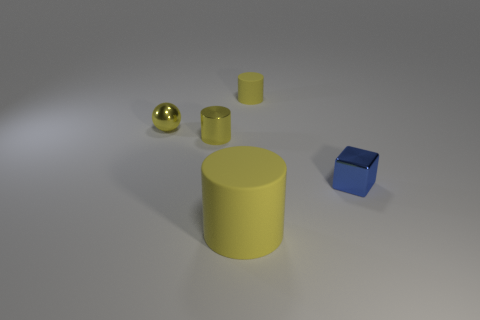What shape is the matte object in front of the matte cylinder right of the yellow object that is in front of the blue shiny cube?
Make the answer very short. Cylinder. Are there any matte cylinders that have the same size as the metal sphere?
Make the answer very short. Yes. The metallic block has what size?
Your answer should be very brief. Small. What number of objects have the same size as the yellow ball?
Provide a succinct answer. 3. Is the number of tiny cylinders in front of the small rubber object less than the number of tiny yellow objects to the right of the large matte thing?
Offer a terse response. No. There is a matte object that is to the left of the yellow rubber object behind the cylinder in front of the cube; what size is it?
Make the answer very short. Large. What is the size of the yellow thing that is behind the tiny metal cylinder and in front of the tiny matte object?
Offer a terse response. Small. There is a tiny thing that is to the right of the cylinder that is on the right side of the big yellow rubber object; what shape is it?
Keep it short and to the point. Cube. Are there any other things of the same color as the shiny ball?
Offer a very short reply. Yes. What shape is the object in front of the tiny shiny block?
Your answer should be very brief. Cylinder. 